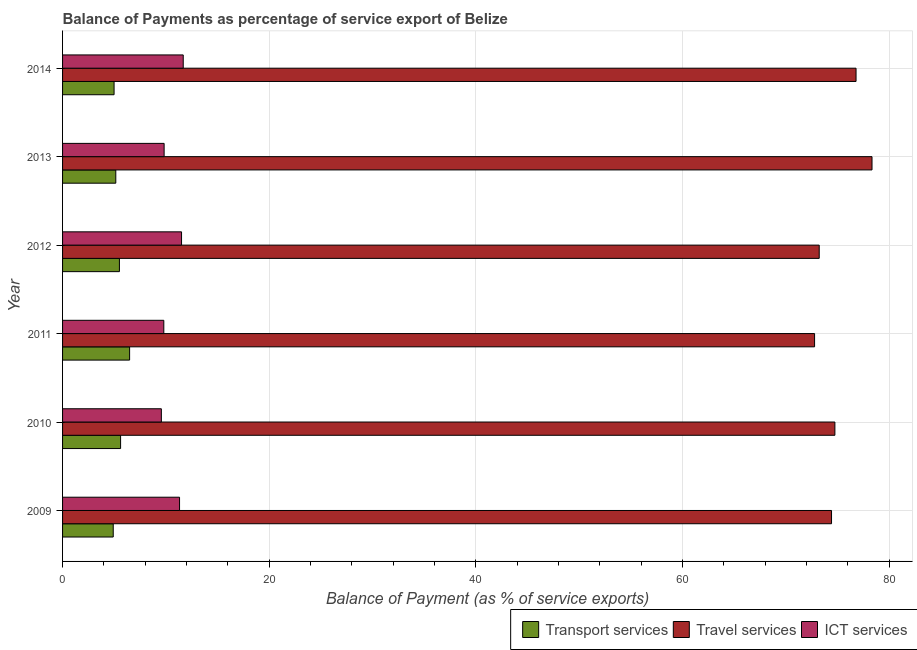How many different coloured bars are there?
Your answer should be very brief. 3. How many groups of bars are there?
Provide a succinct answer. 6. Are the number of bars on each tick of the Y-axis equal?
Offer a terse response. Yes. How many bars are there on the 5th tick from the bottom?
Give a very brief answer. 3. In how many cases, is the number of bars for a given year not equal to the number of legend labels?
Give a very brief answer. 0. What is the balance of payment of ict services in 2012?
Offer a very short reply. 11.51. Across all years, what is the maximum balance of payment of ict services?
Provide a succinct answer. 11.68. Across all years, what is the minimum balance of payment of transport services?
Your answer should be very brief. 4.9. In which year was the balance of payment of ict services maximum?
Your response must be concise. 2014. In which year was the balance of payment of ict services minimum?
Provide a succinct answer. 2010. What is the total balance of payment of ict services in the graph?
Provide a succinct answer. 63.7. What is the difference between the balance of payment of transport services in 2010 and that in 2011?
Provide a succinct answer. -0.87. What is the difference between the balance of payment of ict services in 2013 and the balance of payment of transport services in 2014?
Offer a very short reply. 4.84. What is the average balance of payment of ict services per year?
Provide a short and direct response. 10.62. In the year 2010, what is the difference between the balance of payment of travel services and balance of payment of transport services?
Your response must be concise. 69.12. What is the ratio of the balance of payment of transport services in 2010 to that in 2014?
Provide a succinct answer. 1.13. What is the difference between the highest and the second highest balance of payment of ict services?
Offer a very short reply. 0.16. What is the difference between the highest and the lowest balance of payment of travel services?
Give a very brief answer. 5.56. What does the 2nd bar from the top in 2012 represents?
Your response must be concise. Travel services. What does the 2nd bar from the bottom in 2013 represents?
Give a very brief answer. Travel services. How many bars are there?
Offer a very short reply. 18. Does the graph contain any zero values?
Offer a very short reply. No. How many legend labels are there?
Give a very brief answer. 3. How are the legend labels stacked?
Your answer should be very brief. Horizontal. What is the title of the graph?
Your answer should be compact. Balance of Payments as percentage of service export of Belize. What is the label or title of the X-axis?
Make the answer very short. Balance of Payment (as % of service exports). What is the label or title of the Y-axis?
Your answer should be very brief. Year. What is the Balance of Payment (as % of service exports) of Transport services in 2009?
Offer a very short reply. 4.9. What is the Balance of Payment (as % of service exports) of Travel services in 2009?
Keep it short and to the point. 74.42. What is the Balance of Payment (as % of service exports) of ICT services in 2009?
Give a very brief answer. 11.32. What is the Balance of Payment (as % of service exports) of Transport services in 2010?
Keep it short and to the point. 5.62. What is the Balance of Payment (as % of service exports) in Travel services in 2010?
Your answer should be very brief. 74.74. What is the Balance of Payment (as % of service exports) in ICT services in 2010?
Make the answer very short. 9.56. What is the Balance of Payment (as % of service exports) in Transport services in 2011?
Offer a very short reply. 6.49. What is the Balance of Payment (as % of service exports) in Travel services in 2011?
Keep it short and to the point. 72.78. What is the Balance of Payment (as % of service exports) of ICT services in 2011?
Your answer should be very brief. 9.8. What is the Balance of Payment (as % of service exports) in Transport services in 2012?
Ensure brevity in your answer.  5.5. What is the Balance of Payment (as % of service exports) in Travel services in 2012?
Your answer should be very brief. 73.22. What is the Balance of Payment (as % of service exports) of ICT services in 2012?
Give a very brief answer. 11.51. What is the Balance of Payment (as % of service exports) in Transport services in 2013?
Offer a terse response. 5.15. What is the Balance of Payment (as % of service exports) of Travel services in 2013?
Provide a succinct answer. 78.33. What is the Balance of Payment (as % of service exports) of ICT services in 2013?
Offer a very short reply. 9.83. What is the Balance of Payment (as % of service exports) in Transport services in 2014?
Provide a short and direct response. 4.98. What is the Balance of Payment (as % of service exports) in Travel services in 2014?
Make the answer very short. 76.79. What is the Balance of Payment (as % of service exports) in ICT services in 2014?
Your answer should be very brief. 11.68. Across all years, what is the maximum Balance of Payment (as % of service exports) of Transport services?
Ensure brevity in your answer.  6.49. Across all years, what is the maximum Balance of Payment (as % of service exports) of Travel services?
Provide a short and direct response. 78.33. Across all years, what is the maximum Balance of Payment (as % of service exports) of ICT services?
Provide a short and direct response. 11.68. Across all years, what is the minimum Balance of Payment (as % of service exports) in Transport services?
Your response must be concise. 4.9. Across all years, what is the minimum Balance of Payment (as % of service exports) of Travel services?
Provide a short and direct response. 72.78. Across all years, what is the minimum Balance of Payment (as % of service exports) in ICT services?
Provide a succinct answer. 9.56. What is the total Balance of Payment (as % of service exports) in Transport services in the graph?
Provide a succinct answer. 32.64. What is the total Balance of Payment (as % of service exports) in Travel services in the graph?
Keep it short and to the point. 450.28. What is the total Balance of Payment (as % of service exports) of ICT services in the graph?
Ensure brevity in your answer.  63.7. What is the difference between the Balance of Payment (as % of service exports) in Transport services in 2009 and that in 2010?
Provide a short and direct response. -0.71. What is the difference between the Balance of Payment (as % of service exports) in Travel services in 2009 and that in 2010?
Your response must be concise. -0.32. What is the difference between the Balance of Payment (as % of service exports) in ICT services in 2009 and that in 2010?
Your answer should be compact. 1.76. What is the difference between the Balance of Payment (as % of service exports) of Transport services in 2009 and that in 2011?
Keep it short and to the point. -1.59. What is the difference between the Balance of Payment (as % of service exports) in Travel services in 2009 and that in 2011?
Give a very brief answer. 1.64. What is the difference between the Balance of Payment (as % of service exports) in ICT services in 2009 and that in 2011?
Provide a succinct answer. 1.52. What is the difference between the Balance of Payment (as % of service exports) of Transport services in 2009 and that in 2012?
Offer a terse response. -0.6. What is the difference between the Balance of Payment (as % of service exports) of Travel services in 2009 and that in 2012?
Your answer should be very brief. 1.19. What is the difference between the Balance of Payment (as % of service exports) of ICT services in 2009 and that in 2012?
Ensure brevity in your answer.  -0.19. What is the difference between the Balance of Payment (as % of service exports) of Transport services in 2009 and that in 2013?
Offer a terse response. -0.25. What is the difference between the Balance of Payment (as % of service exports) in Travel services in 2009 and that in 2013?
Provide a succinct answer. -3.92. What is the difference between the Balance of Payment (as % of service exports) of ICT services in 2009 and that in 2013?
Give a very brief answer. 1.49. What is the difference between the Balance of Payment (as % of service exports) of Transport services in 2009 and that in 2014?
Your answer should be compact. -0.08. What is the difference between the Balance of Payment (as % of service exports) in Travel services in 2009 and that in 2014?
Your answer should be very brief. -2.37. What is the difference between the Balance of Payment (as % of service exports) in ICT services in 2009 and that in 2014?
Your response must be concise. -0.36. What is the difference between the Balance of Payment (as % of service exports) of Transport services in 2010 and that in 2011?
Offer a very short reply. -0.87. What is the difference between the Balance of Payment (as % of service exports) of Travel services in 2010 and that in 2011?
Offer a terse response. 1.96. What is the difference between the Balance of Payment (as % of service exports) in ICT services in 2010 and that in 2011?
Your answer should be very brief. -0.24. What is the difference between the Balance of Payment (as % of service exports) in Transport services in 2010 and that in 2012?
Provide a succinct answer. 0.11. What is the difference between the Balance of Payment (as % of service exports) of Travel services in 2010 and that in 2012?
Provide a short and direct response. 1.52. What is the difference between the Balance of Payment (as % of service exports) in ICT services in 2010 and that in 2012?
Provide a short and direct response. -1.95. What is the difference between the Balance of Payment (as % of service exports) of Transport services in 2010 and that in 2013?
Offer a very short reply. 0.47. What is the difference between the Balance of Payment (as % of service exports) in Travel services in 2010 and that in 2013?
Your response must be concise. -3.59. What is the difference between the Balance of Payment (as % of service exports) of ICT services in 2010 and that in 2013?
Provide a short and direct response. -0.27. What is the difference between the Balance of Payment (as % of service exports) in Transport services in 2010 and that in 2014?
Ensure brevity in your answer.  0.63. What is the difference between the Balance of Payment (as % of service exports) of Travel services in 2010 and that in 2014?
Give a very brief answer. -2.05. What is the difference between the Balance of Payment (as % of service exports) of ICT services in 2010 and that in 2014?
Provide a short and direct response. -2.12. What is the difference between the Balance of Payment (as % of service exports) of Travel services in 2011 and that in 2012?
Provide a short and direct response. -0.45. What is the difference between the Balance of Payment (as % of service exports) in ICT services in 2011 and that in 2012?
Keep it short and to the point. -1.72. What is the difference between the Balance of Payment (as % of service exports) of Transport services in 2011 and that in 2013?
Provide a short and direct response. 1.34. What is the difference between the Balance of Payment (as % of service exports) of Travel services in 2011 and that in 2013?
Make the answer very short. -5.56. What is the difference between the Balance of Payment (as % of service exports) in ICT services in 2011 and that in 2013?
Offer a very short reply. -0.03. What is the difference between the Balance of Payment (as % of service exports) of Transport services in 2011 and that in 2014?
Give a very brief answer. 1.5. What is the difference between the Balance of Payment (as % of service exports) of Travel services in 2011 and that in 2014?
Provide a short and direct response. -4.01. What is the difference between the Balance of Payment (as % of service exports) in ICT services in 2011 and that in 2014?
Your response must be concise. -1.88. What is the difference between the Balance of Payment (as % of service exports) in Transport services in 2012 and that in 2013?
Give a very brief answer. 0.35. What is the difference between the Balance of Payment (as % of service exports) of Travel services in 2012 and that in 2013?
Provide a succinct answer. -5.11. What is the difference between the Balance of Payment (as % of service exports) of ICT services in 2012 and that in 2013?
Ensure brevity in your answer.  1.69. What is the difference between the Balance of Payment (as % of service exports) of Transport services in 2012 and that in 2014?
Ensure brevity in your answer.  0.52. What is the difference between the Balance of Payment (as % of service exports) of Travel services in 2012 and that in 2014?
Provide a short and direct response. -3.56. What is the difference between the Balance of Payment (as % of service exports) in ICT services in 2012 and that in 2014?
Give a very brief answer. -0.16. What is the difference between the Balance of Payment (as % of service exports) of Transport services in 2013 and that in 2014?
Your answer should be compact. 0.17. What is the difference between the Balance of Payment (as % of service exports) of Travel services in 2013 and that in 2014?
Provide a short and direct response. 1.55. What is the difference between the Balance of Payment (as % of service exports) in ICT services in 2013 and that in 2014?
Keep it short and to the point. -1.85. What is the difference between the Balance of Payment (as % of service exports) of Transport services in 2009 and the Balance of Payment (as % of service exports) of Travel services in 2010?
Keep it short and to the point. -69.84. What is the difference between the Balance of Payment (as % of service exports) in Transport services in 2009 and the Balance of Payment (as % of service exports) in ICT services in 2010?
Your response must be concise. -4.66. What is the difference between the Balance of Payment (as % of service exports) in Travel services in 2009 and the Balance of Payment (as % of service exports) in ICT services in 2010?
Your answer should be compact. 64.86. What is the difference between the Balance of Payment (as % of service exports) of Transport services in 2009 and the Balance of Payment (as % of service exports) of Travel services in 2011?
Offer a terse response. -67.87. What is the difference between the Balance of Payment (as % of service exports) in Transport services in 2009 and the Balance of Payment (as % of service exports) in ICT services in 2011?
Give a very brief answer. -4.89. What is the difference between the Balance of Payment (as % of service exports) in Travel services in 2009 and the Balance of Payment (as % of service exports) in ICT services in 2011?
Ensure brevity in your answer.  64.62. What is the difference between the Balance of Payment (as % of service exports) of Transport services in 2009 and the Balance of Payment (as % of service exports) of Travel services in 2012?
Offer a very short reply. -68.32. What is the difference between the Balance of Payment (as % of service exports) of Transport services in 2009 and the Balance of Payment (as % of service exports) of ICT services in 2012?
Ensure brevity in your answer.  -6.61. What is the difference between the Balance of Payment (as % of service exports) in Travel services in 2009 and the Balance of Payment (as % of service exports) in ICT services in 2012?
Ensure brevity in your answer.  62.9. What is the difference between the Balance of Payment (as % of service exports) of Transport services in 2009 and the Balance of Payment (as % of service exports) of Travel services in 2013?
Your response must be concise. -73.43. What is the difference between the Balance of Payment (as % of service exports) in Transport services in 2009 and the Balance of Payment (as % of service exports) in ICT services in 2013?
Provide a short and direct response. -4.93. What is the difference between the Balance of Payment (as % of service exports) in Travel services in 2009 and the Balance of Payment (as % of service exports) in ICT services in 2013?
Provide a short and direct response. 64.59. What is the difference between the Balance of Payment (as % of service exports) of Transport services in 2009 and the Balance of Payment (as % of service exports) of Travel services in 2014?
Make the answer very short. -71.89. What is the difference between the Balance of Payment (as % of service exports) in Transport services in 2009 and the Balance of Payment (as % of service exports) in ICT services in 2014?
Give a very brief answer. -6.77. What is the difference between the Balance of Payment (as % of service exports) of Travel services in 2009 and the Balance of Payment (as % of service exports) of ICT services in 2014?
Provide a short and direct response. 62.74. What is the difference between the Balance of Payment (as % of service exports) of Transport services in 2010 and the Balance of Payment (as % of service exports) of Travel services in 2011?
Your answer should be very brief. -67.16. What is the difference between the Balance of Payment (as % of service exports) of Transport services in 2010 and the Balance of Payment (as % of service exports) of ICT services in 2011?
Provide a short and direct response. -4.18. What is the difference between the Balance of Payment (as % of service exports) of Travel services in 2010 and the Balance of Payment (as % of service exports) of ICT services in 2011?
Offer a terse response. 64.94. What is the difference between the Balance of Payment (as % of service exports) of Transport services in 2010 and the Balance of Payment (as % of service exports) of Travel services in 2012?
Keep it short and to the point. -67.61. What is the difference between the Balance of Payment (as % of service exports) of Transport services in 2010 and the Balance of Payment (as % of service exports) of ICT services in 2012?
Make the answer very short. -5.9. What is the difference between the Balance of Payment (as % of service exports) in Travel services in 2010 and the Balance of Payment (as % of service exports) in ICT services in 2012?
Offer a very short reply. 63.23. What is the difference between the Balance of Payment (as % of service exports) of Transport services in 2010 and the Balance of Payment (as % of service exports) of Travel services in 2013?
Keep it short and to the point. -72.72. What is the difference between the Balance of Payment (as % of service exports) of Transport services in 2010 and the Balance of Payment (as % of service exports) of ICT services in 2013?
Keep it short and to the point. -4.21. What is the difference between the Balance of Payment (as % of service exports) in Travel services in 2010 and the Balance of Payment (as % of service exports) in ICT services in 2013?
Keep it short and to the point. 64.91. What is the difference between the Balance of Payment (as % of service exports) of Transport services in 2010 and the Balance of Payment (as % of service exports) of Travel services in 2014?
Offer a very short reply. -71.17. What is the difference between the Balance of Payment (as % of service exports) in Transport services in 2010 and the Balance of Payment (as % of service exports) in ICT services in 2014?
Your answer should be compact. -6.06. What is the difference between the Balance of Payment (as % of service exports) of Travel services in 2010 and the Balance of Payment (as % of service exports) of ICT services in 2014?
Give a very brief answer. 63.06. What is the difference between the Balance of Payment (as % of service exports) of Transport services in 2011 and the Balance of Payment (as % of service exports) of Travel services in 2012?
Offer a terse response. -66.74. What is the difference between the Balance of Payment (as % of service exports) in Transport services in 2011 and the Balance of Payment (as % of service exports) in ICT services in 2012?
Your answer should be compact. -5.03. What is the difference between the Balance of Payment (as % of service exports) in Travel services in 2011 and the Balance of Payment (as % of service exports) in ICT services in 2012?
Ensure brevity in your answer.  61.26. What is the difference between the Balance of Payment (as % of service exports) in Transport services in 2011 and the Balance of Payment (as % of service exports) in Travel services in 2013?
Your answer should be compact. -71.85. What is the difference between the Balance of Payment (as % of service exports) of Transport services in 2011 and the Balance of Payment (as % of service exports) of ICT services in 2013?
Offer a terse response. -3.34. What is the difference between the Balance of Payment (as % of service exports) of Travel services in 2011 and the Balance of Payment (as % of service exports) of ICT services in 2013?
Offer a terse response. 62.95. What is the difference between the Balance of Payment (as % of service exports) in Transport services in 2011 and the Balance of Payment (as % of service exports) in Travel services in 2014?
Keep it short and to the point. -70.3. What is the difference between the Balance of Payment (as % of service exports) of Transport services in 2011 and the Balance of Payment (as % of service exports) of ICT services in 2014?
Ensure brevity in your answer.  -5.19. What is the difference between the Balance of Payment (as % of service exports) of Travel services in 2011 and the Balance of Payment (as % of service exports) of ICT services in 2014?
Provide a succinct answer. 61.1. What is the difference between the Balance of Payment (as % of service exports) of Transport services in 2012 and the Balance of Payment (as % of service exports) of Travel services in 2013?
Keep it short and to the point. -72.83. What is the difference between the Balance of Payment (as % of service exports) in Transport services in 2012 and the Balance of Payment (as % of service exports) in ICT services in 2013?
Offer a very short reply. -4.33. What is the difference between the Balance of Payment (as % of service exports) in Travel services in 2012 and the Balance of Payment (as % of service exports) in ICT services in 2013?
Keep it short and to the point. 63.4. What is the difference between the Balance of Payment (as % of service exports) in Transport services in 2012 and the Balance of Payment (as % of service exports) in Travel services in 2014?
Your answer should be compact. -71.29. What is the difference between the Balance of Payment (as % of service exports) of Transport services in 2012 and the Balance of Payment (as % of service exports) of ICT services in 2014?
Ensure brevity in your answer.  -6.18. What is the difference between the Balance of Payment (as % of service exports) in Travel services in 2012 and the Balance of Payment (as % of service exports) in ICT services in 2014?
Your answer should be very brief. 61.55. What is the difference between the Balance of Payment (as % of service exports) in Transport services in 2013 and the Balance of Payment (as % of service exports) in Travel services in 2014?
Provide a short and direct response. -71.64. What is the difference between the Balance of Payment (as % of service exports) in Transport services in 2013 and the Balance of Payment (as % of service exports) in ICT services in 2014?
Your answer should be compact. -6.53. What is the difference between the Balance of Payment (as % of service exports) of Travel services in 2013 and the Balance of Payment (as % of service exports) of ICT services in 2014?
Ensure brevity in your answer.  66.66. What is the average Balance of Payment (as % of service exports) of Transport services per year?
Give a very brief answer. 5.44. What is the average Balance of Payment (as % of service exports) in Travel services per year?
Provide a short and direct response. 75.05. What is the average Balance of Payment (as % of service exports) of ICT services per year?
Give a very brief answer. 10.62. In the year 2009, what is the difference between the Balance of Payment (as % of service exports) in Transport services and Balance of Payment (as % of service exports) in Travel services?
Your answer should be compact. -69.51. In the year 2009, what is the difference between the Balance of Payment (as % of service exports) of Transport services and Balance of Payment (as % of service exports) of ICT services?
Provide a short and direct response. -6.42. In the year 2009, what is the difference between the Balance of Payment (as % of service exports) in Travel services and Balance of Payment (as % of service exports) in ICT services?
Keep it short and to the point. 63.1. In the year 2010, what is the difference between the Balance of Payment (as % of service exports) in Transport services and Balance of Payment (as % of service exports) in Travel services?
Your answer should be compact. -69.12. In the year 2010, what is the difference between the Balance of Payment (as % of service exports) of Transport services and Balance of Payment (as % of service exports) of ICT services?
Offer a very short reply. -3.95. In the year 2010, what is the difference between the Balance of Payment (as % of service exports) in Travel services and Balance of Payment (as % of service exports) in ICT services?
Your response must be concise. 65.18. In the year 2011, what is the difference between the Balance of Payment (as % of service exports) of Transport services and Balance of Payment (as % of service exports) of Travel services?
Ensure brevity in your answer.  -66.29. In the year 2011, what is the difference between the Balance of Payment (as % of service exports) of Transport services and Balance of Payment (as % of service exports) of ICT services?
Your answer should be very brief. -3.31. In the year 2011, what is the difference between the Balance of Payment (as % of service exports) of Travel services and Balance of Payment (as % of service exports) of ICT services?
Offer a terse response. 62.98. In the year 2012, what is the difference between the Balance of Payment (as % of service exports) in Transport services and Balance of Payment (as % of service exports) in Travel services?
Offer a terse response. -67.72. In the year 2012, what is the difference between the Balance of Payment (as % of service exports) in Transport services and Balance of Payment (as % of service exports) in ICT services?
Offer a terse response. -6.01. In the year 2012, what is the difference between the Balance of Payment (as % of service exports) in Travel services and Balance of Payment (as % of service exports) in ICT services?
Keep it short and to the point. 61.71. In the year 2013, what is the difference between the Balance of Payment (as % of service exports) of Transport services and Balance of Payment (as % of service exports) of Travel services?
Offer a terse response. -73.18. In the year 2013, what is the difference between the Balance of Payment (as % of service exports) in Transport services and Balance of Payment (as % of service exports) in ICT services?
Keep it short and to the point. -4.68. In the year 2013, what is the difference between the Balance of Payment (as % of service exports) in Travel services and Balance of Payment (as % of service exports) in ICT services?
Ensure brevity in your answer.  68.51. In the year 2014, what is the difference between the Balance of Payment (as % of service exports) in Transport services and Balance of Payment (as % of service exports) in Travel services?
Make the answer very short. -71.8. In the year 2014, what is the difference between the Balance of Payment (as % of service exports) of Transport services and Balance of Payment (as % of service exports) of ICT services?
Offer a terse response. -6.69. In the year 2014, what is the difference between the Balance of Payment (as % of service exports) of Travel services and Balance of Payment (as % of service exports) of ICT services?
Ensure brevity in your answer.  65.11. What is the ratio of the Balance of Payment (as % of service exports) in Transport services in 2009 to that in 2010?
Offer a terse response. 0.87. What is the ratio of the Balance of Payment (as % of service exports) in ICT services in 2009 to that in 2010?
Give a very brief answer. 1.18. What is the ratio of the Balance of Payment (as % of service exports) of Transport services in 2009 to that in 2011?
Your answer should be compact. 0.76. What is the ratio of the Balance of Payment (as % of service exports) in Travel services in 2009 to that in 2011?
Give a very brief answer. 1.02. What is the ratio of the Balance of Payment (as % of service exports) in ICT services in 2009 to that in 2011?
Your answer should be compact. 1.16. What is the ratio of the Balance of Payment (as % of service exports) in Transport services in 2009 to that in 2012?
Make the answer very short. 0.89. What is the ratio of the Balance of Payment (as % of service exports) of Travel services in 2009 to that in 2012?
Provide a short and direct response. 1.02. What is the ratio of the Balance of Payment (as % of service exports) in ICT services in 2009 to that in 2012?
Your response must be concise. 0.98. What is the ratio of the Balance of Payment (as % of service exports) in ICT services in 2009 to that in 2013?
Give a very brief answer. 1.15. What is the ratio of the Balance of Payment (as % of service exports) of Transport services in 2009 to that in 2014?
Provide a short and direct response. 0.98. What is the ratio of the Balance of Payment (as % of service exports) of Travel services in 2009 to that in 2014?
Give a very brief answer. 0.97. What is the ratio of the Balance of Payment (as % of service exports) of ICT services in 2009 to that in 2014?
Your response must be concise. 0.97. What is the ratio of the Balance of Payment (as % of service exports) of Transport services in 2010 to that in 2011?
Your response must be concise. 0.87. What is the ratio of the Balance of Payment (as % of service exports) of ICT services in 2010 to that in 2011?
Offer a very short reply. 0.98. What is the ratio of the Balance of Payment (as % of service exports) of Transport services in 2010 to that in 2012?
Your answer should be compact. 1.02. What is the ratio of the Balance of Payment (as % of service exports) in Travel services in 2010 to that in 2012?
Offer a very short reply. 1.02. What is the ratio of the Balance of Payment (as % of service exports) of ICT services in 2010 to that in 2012?
Offer a terse response. 0.83. What is the ratio of the Balance of Payment (as % of service exports) in Transport services in 2010 to that in 2013?
Your response must be concise. 1.09. What is the ratio of the Balance of Payment (as % of service exports) in Travel services in 2010 to that in 2013?
Your answer should be very brief. 0.95. What is the ratio of the Balance of Payment (as % of service exports) in ICT services in 2010 to that in 2013?
Ensure brevity in your answer.  0.97. What is the ratio of the Balance of Payment (as % of service exports) of Transport services in 2010 to that in 2014?
Your answer should be very brief. 1.13. What is the ratio of the Balance of Payment (as % of service exports) of Travel services in 2010 to that in 2014?
Give a very brief answer. 0.97. What is the ratio of the Balance of Payment (as % of service exports) of ICT services in 2010 to that in 2014?
Your answer should be very brief. 0.82. What is the ratio of the Balance of Payment (as % of service exports) of Transport services in 2011 to that in 2012?
Your answer should be compact. 1.18. What is the ratio of the Balance of Payment (as % of service exports) of ICT services in 2011 to that in 2012?
Your answer should be compact. 0.85. What is the ratio of the Balance of Payment (as % of service exports) of Transport services in 2011 to that in 2013?
Ensure brevity in your answer.  1.26. What is the ratio of the Balance of Payment (as % of service exports) of Travel services in 2011 to that in 2013?
Provide a succinct answer. 0.93. What is the ratio of the Balance of Payment (as % of service exports) in ICT services in 2011 to that in 2013?
Your answer should be very brief. 1. What is the ratio of the Balance of Payment (as % of service exports) of Transport services in 2011 to that in 2014?
Your answer should be compact. 1.3. What is the ratio of the Balance of Payment (as % of service exports) of Travel services in 2011 to that in 2014?
Give a very brief answer. 0.95. What is the ratio of the Balance of Payment (as % of service exports) of ICT services in 2011 to that in 2014?
Keep it short and to the point. 0.84. What is the ratio of the Balance of Payment (as % of service exports) in Transport services in 2012 to that in 2013?
Make the answer very short. 1.07. What is the ratio of the Balance of Payment (as % of service exports) in Travel services in 2012 to that in 2013?
Offer a very short reply. 0.93. What is the ratio of the Balance of Payment (as % of service exports) of ICT services in 2012 to that in 2013?
Offer a terse response. 1.17. What is the ratio of the Balance of Payment (as % of service exports) of Transport services in 2012 to that in 2014?
Your response must be concise. 1.1. What is the ratio of the Balance of Payment (as % of service exports) in Travel services in 2012 to that in 2014?
Provide a short and direct response. 0.95. What is the ratio of the Balance of Payment (as % of service exports) in ICT services in 2012 to that in 2014?
Ensure brevity in your answer.  0.99. What is the ratio of the Balance of Payment (as % of service exports) of Travel services in 2013 to that in 2014?
Your answer should be compact. 1.02. What is the ratio of the Balance of Payment (as % of service exports) of ICT services in 2013 to that in 2014?
Provide a succinct answer. 0.84. What is the difference between the highest and the second highest Balance of Payment (as % of service exports) of Transport services?
Provide a short and direct response. 0.87. What is the difference between the highest and the second highest Balance of Payment (as % of service exports) in Travel services?
Your answer should be compact. 1.55. What is the difference between the highest and the second highest Balance of Payment (as % of service exports) of ICT services?
Offer a terse response. 0.16. What is the difference between the highest and the lowest Balance of Payment (as % of service exports) of Transport services?
Your answer should be very brief. 1.59. What is the difference between the highest and the lowest Balance of Payment (as % of service exports) in Travel services?
Offer a very short reply. 5.56. What is the difference between the highest and the lowest Balance of Payment (as % of service exports) in ICT services?
Offer a terse response. 2.12. 